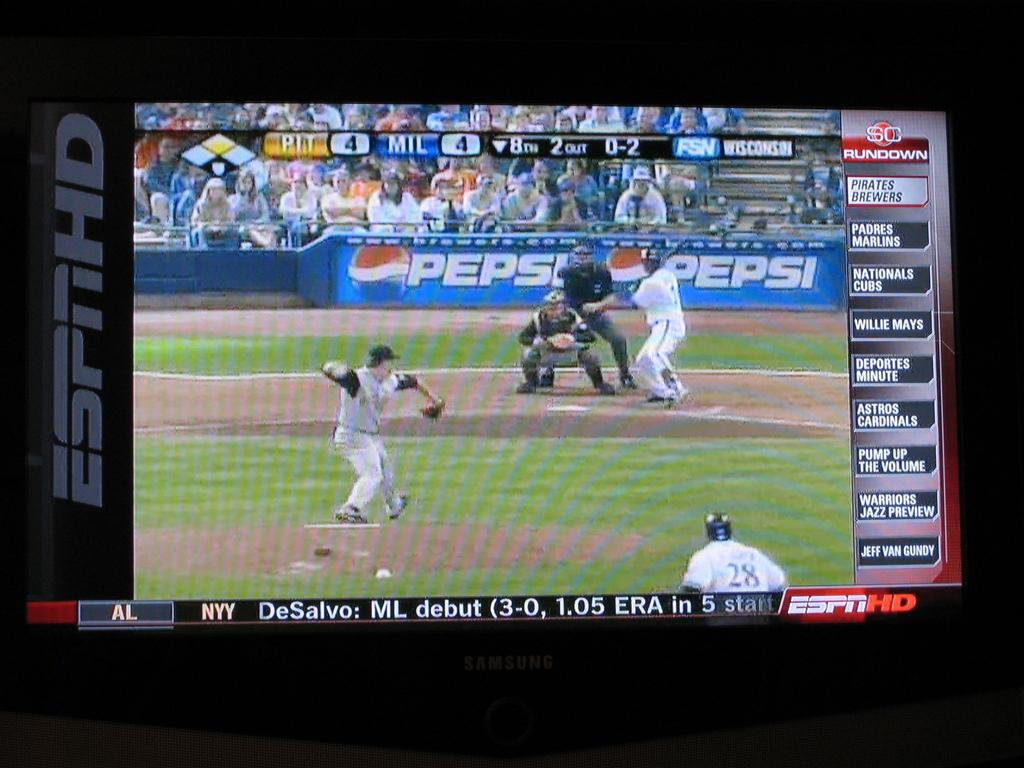<image>
Relay a brief, clear account of the picture shown. Screen which says ESPNHD on it with people pitching. 